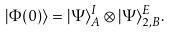Convert formula to latex. <formula><loc_0><loc_0><loc_500><loc_500>| \Phi ( 0 ) \rangle = | \Psi \rangle ^ { I } _ { A } \otimes | \Psi \rangle ^ { E } _ { 2 , B } .</formula> 